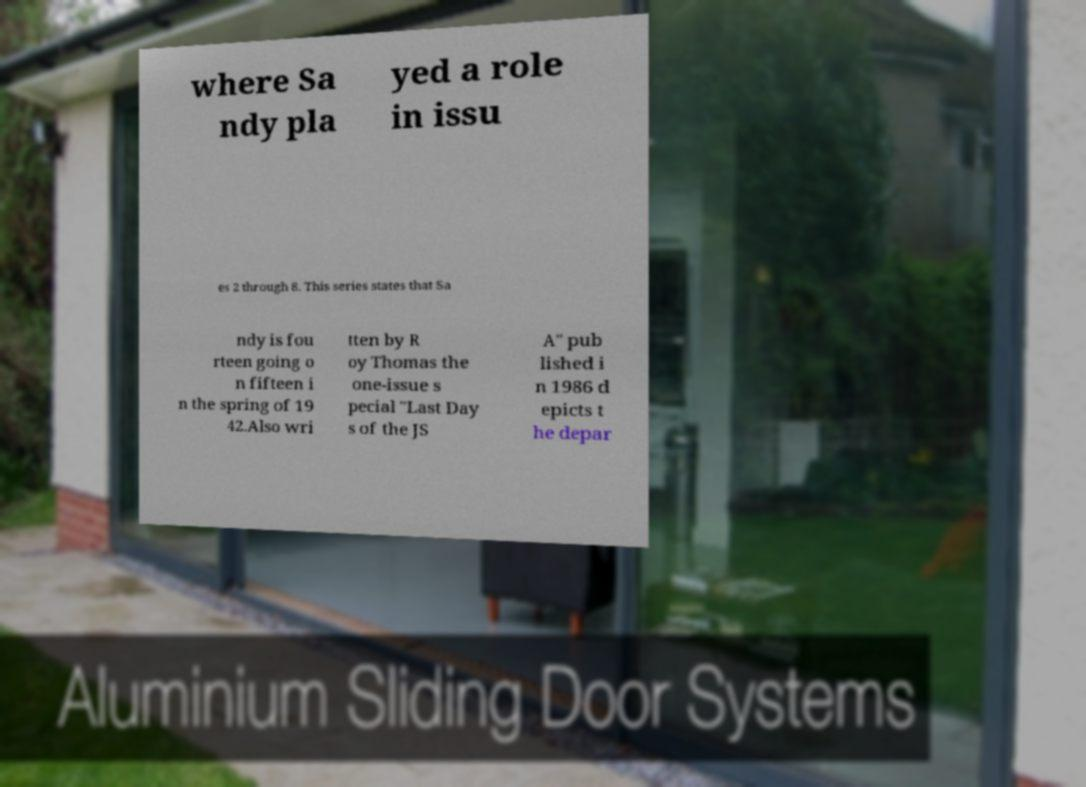Please read and relay the text visible in this image. What does it say? where Sa ndy pla yed a role in issu es 2 through 8. This series states that Sa ndy is fou rteen going o n fifteen i n the spring of 19 42.Also wri tten by R oy Thomas the one-issue s pecial "Last Day s of the JS A" pub lished i n 1986 d epicts t he depar 